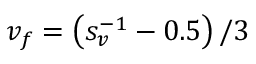Convert formula to latex. <formula><loc_0><loc_0><loc_500><loc_500>v _ { f } = \left ( s _ { v } ^ { - 1 } - 0 . 5 \right ) / 3</formula> 